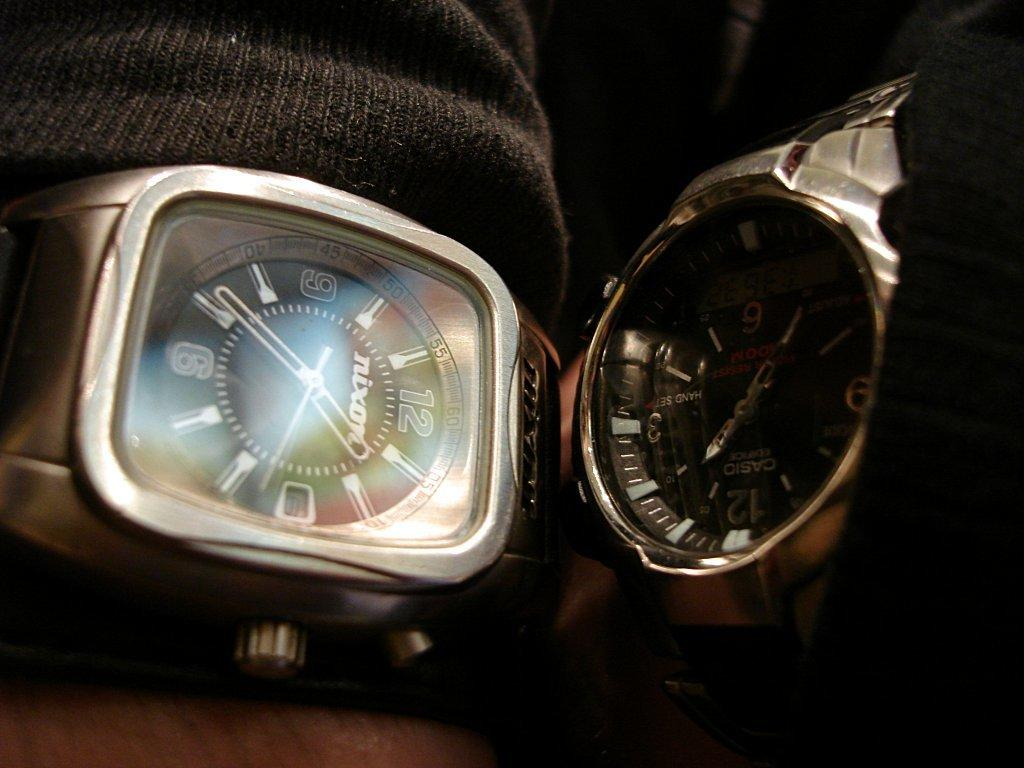<image>
Share a concise interpretation of the image provided. Two wristwatches next to one another with one that says NIXON on the face. 